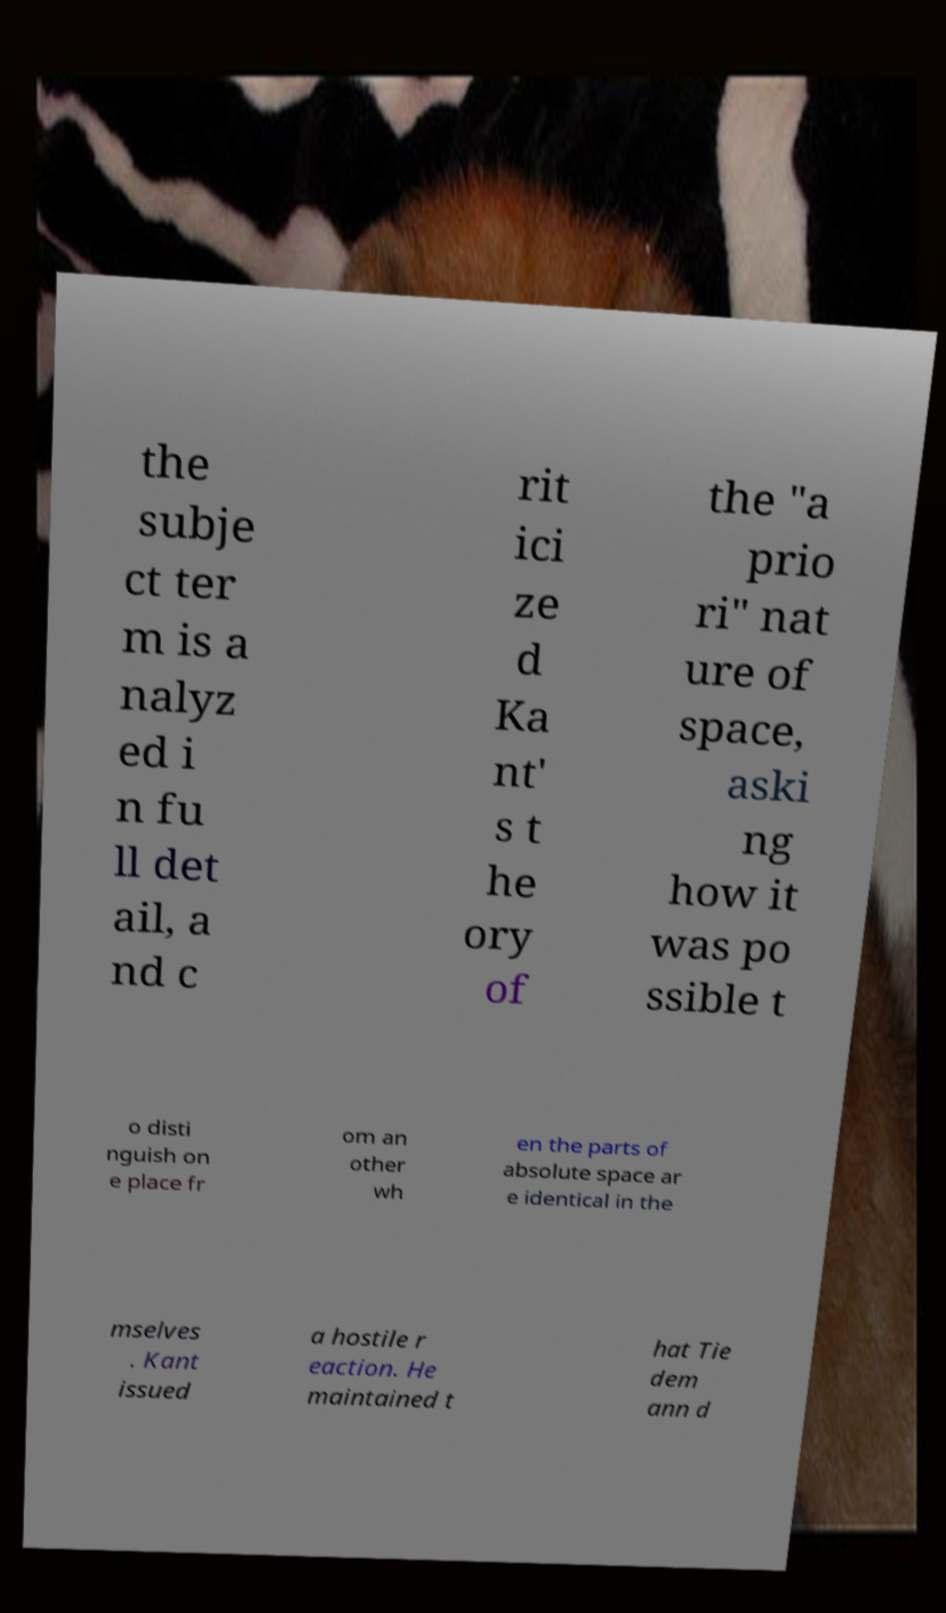Please read and relay the text visible in this image. What does it say? the subje ct ter m is a nalyz ed i n fu ll det ail, a nd c rit ici ze d Ka nt' s t he ory of the "a prio ri" nat ure of space, aski ng how it was po ssible t o disti nguish on e place fr om an other wh en the parts of absolute space ar e identical in the mselves . Kant issued a hostile r eaction. He maintained t hat Tie dem ann d 